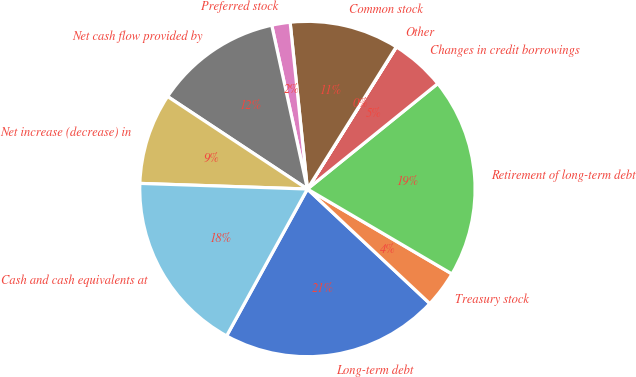<chart> <loc_0><loc_0><loc_500><loc_500><pie_chart><fcel>Long-term debt<fcel>Treasury stock<fcel>Retirement of long-term debt<fcel>Changes in credit borrowings<fcel>Other<fcel>Common stock<fcel>Preferred stock<fcel>Net cash flow provided by<fcel>Net increase (decrease) in<fcel>Cash and cash equivalents at<nl><fcel>21.03%<fcel>3.52%<fcel>19.28%<fcel>5.27%<fcel>0.02%<fcel>10.53%<fcel>1.77%<fcel>12.28%<fcel>8.77%<fcel>17.53%<nl></chart> 